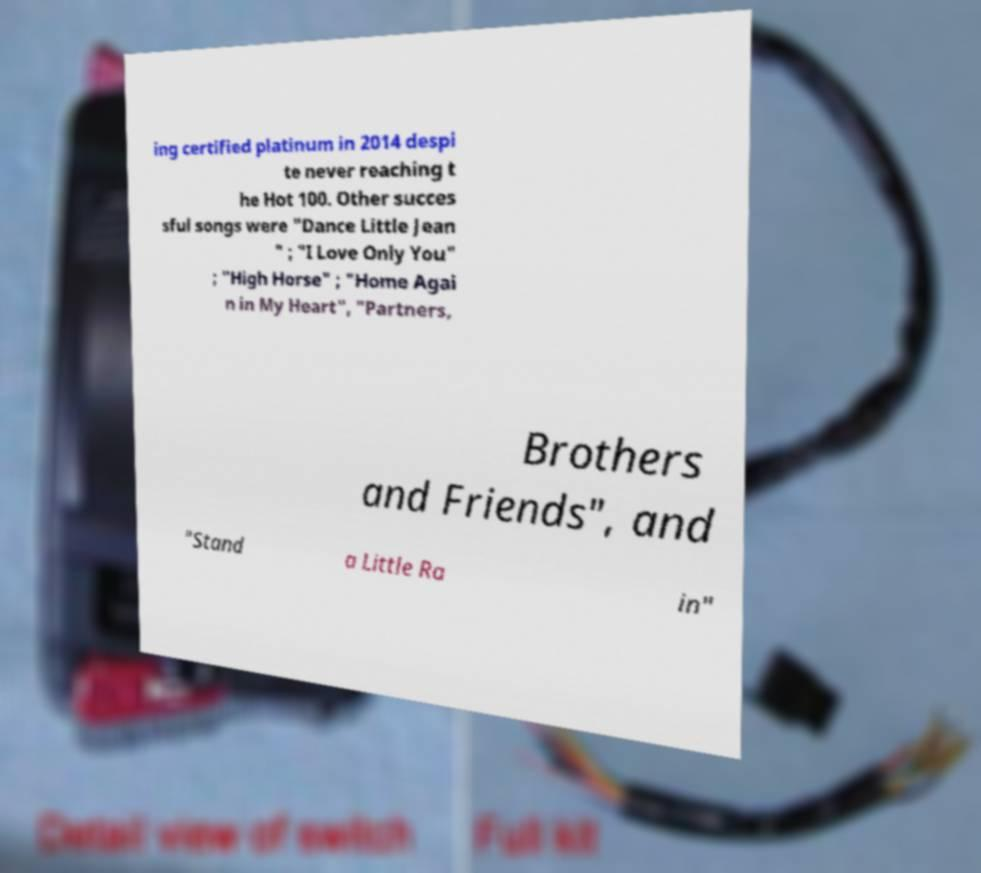There's text embedded in this image that I need extracted. Can you transcribe it verbatim? ing certified platinum in 2014 despi te never reaching t he Hot 100. Other succes sful songs were "Dance Little Jean " ; "I Love Only You" ; "High Horse" ; "Home Agai n in My Heart", "Partners, Brothers and Friends", and "Stand a Little Ra in" 